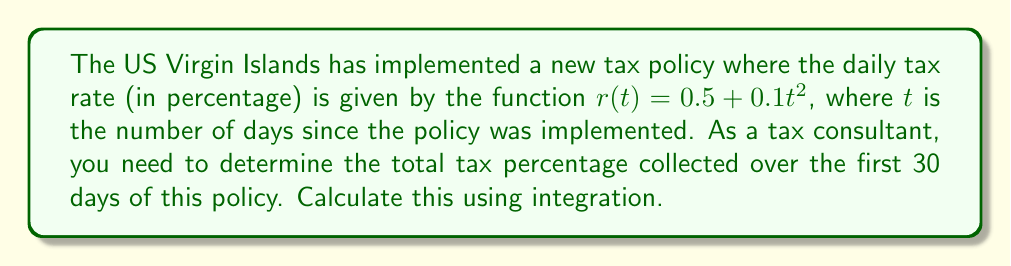Help me with this question. To solve this problem, we need to integrate the tax rate function over the given time period. Here's the step-by-step solution:

1) The tax rate function is given by:
   $r(t) = 0.5 + 0.1t^2$

2) We need to integrate this function from day 0 to day 30:
   $$\int_0^{30} (0.5 + 0.1t^2) dt$$

3) Let's split this into two integrals:
   $$\int_0^{30} 0.5 dt + \int_0^{30} 0.1t^2 dt$$

4) Integrate the first part:
   $$0.5t \bigg|_0^{30} + \int_0^{30} 0.1t^2 dt$$

5) Integrate the second part:
   $$0.5t \bigg|_0^{30} + \frac{0.1t^3}{3} \bigg|_0^{30}$$

6) Evaluate the integrals:
   $$(0.5 \cdot 30 - 0.5 \cdot 0) + (\frac{0.1 \cdot 30^3}{3} - \frac{0.1 \cdot 0^3}{3})$$

7) Simplify:
   $$15 + \frac{0.1 \cdot 27000}{3} = 15 + 900 = 915$$

Therefore, the total tax percentage collected over the 30-day period is 915%.
Answer: 915% 